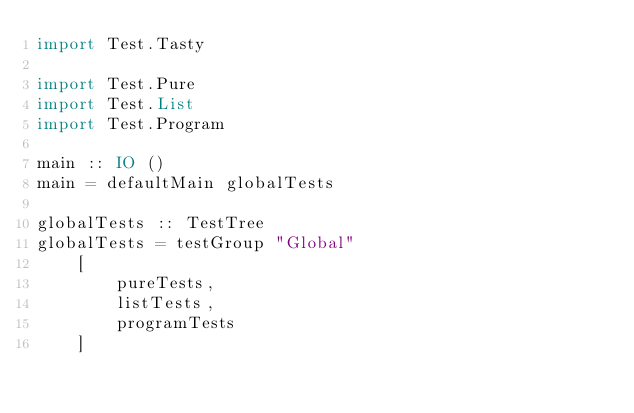Convert code to text. <code><loc_0><loc_0><loc_500><loc_500><_Haskell_>import Test.Tasty

import Test.Pure
import Test.List
import Test.Program

main :: IO ()
main = defaultMain globalTests

globalTests :: TestTree
globalTests = testGroup "Global"
    [
        pureTests,
        listTests,
        programTests
    ]</code> 